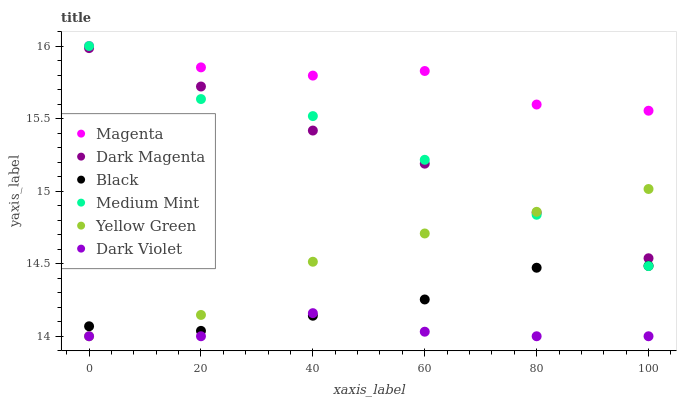Does Dark Violet have the minimum area under the curve?
Answer yes or no. Yes. Does Magenta have the maximum area under the curve?
Answer yes or no. Yes. Does Dark Magenta have the minimum area under the curve?
Answer yes or no. No. Does Dark Magenta have the maximum area under the curve?
Answer yes or no. No. Is Dark Magenta the smoothest?
Answer yes or no. Yes. Is Magenta the roughest?
Answer yes or no. Yes. Is Dark Violet the smoothest?
Answer yes or no. No. Is Dark Violet the roughest?
Answer yes or no. No. Does Dark Violet have the lowest value?
Answer yes or no. Yes. Does Dark Magenta have the lowest value?
Answer yes or no. No. Does Magenta have the highest value?
Answer yes or no. Yes. Does Dark Magenta have the highest value?
Answer yes or no. No. Is Yellow Green less than Magenta?
Answer yes or no. Yes. Is Medium Mint greater than Dark Violet?
Answer yes or no. Yes. Does Yellow Green intersect Dark Magenta?
Answer yes or no. Yes. Is Yellow Green less than Dark Magenta?
Answer yes or no. No. Is Yellow Green greater than Dark Magenta?
Answer yes or no. No. Does Yellow Green intersect Magenta?
Answer yes or no. No. 